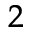Convert formula to latex. <formula><loc_0><loc_0><loc_500><loc_500>^ { 2 }</formula> 